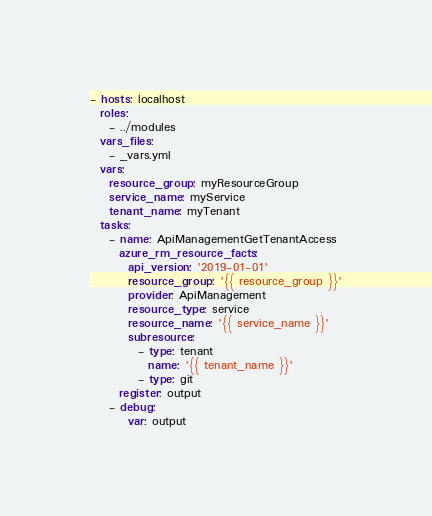<code> <loc_0><loc_0><loc_500><loc_500><_YAML_>- hosts: localhost
  roles:
    - ../modules
  vars_files:
    - _vars.yml
  vars:
    resource_group: myResourceGroup
    service_name: myService
    tenant_name: myTenant
  tasks:
    - name: ApiManagementGetTenantAccess
      azure_rm_resource_facts:
        api_version: '2019-01-01'
        resource_group: '{{ resource_group }}'
        provider: ApiManagement
        resource_type: service
        resource_name: '{{ service_name }}'
        subresource:
          - type: tenant
            name: '{{ tenant_name }}'
          - type: git
      register: output
    - debug:
        var: output
</code> 